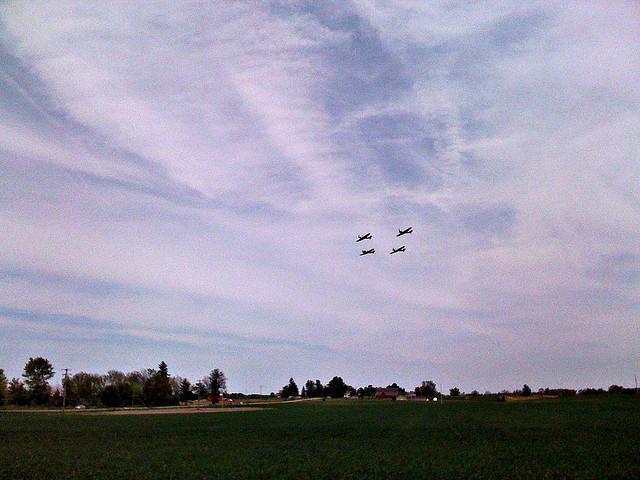How many planes are flying in formation?
Give a very brief answer. 4. How many planes are there?
Give a very brief answer. 4. How many birds are flying around?
Give a very brief answer. 4. 